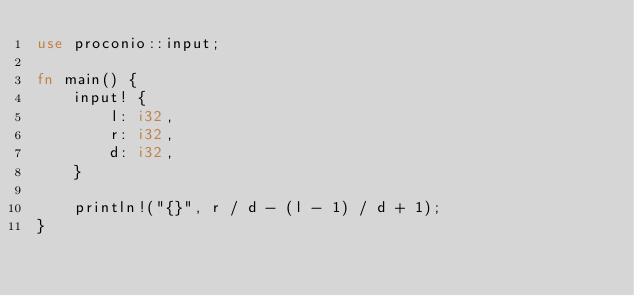Convert code to text. <code><loc_0><loc_0><loc_500><loc_500><_Rust_>use proconio::input;

fn main() {
    input! {
        l: i32,
        r: i32,
        d: i32,
    }

    println!("{}", r / d - (l - 1) / d + 1);
}</code> 